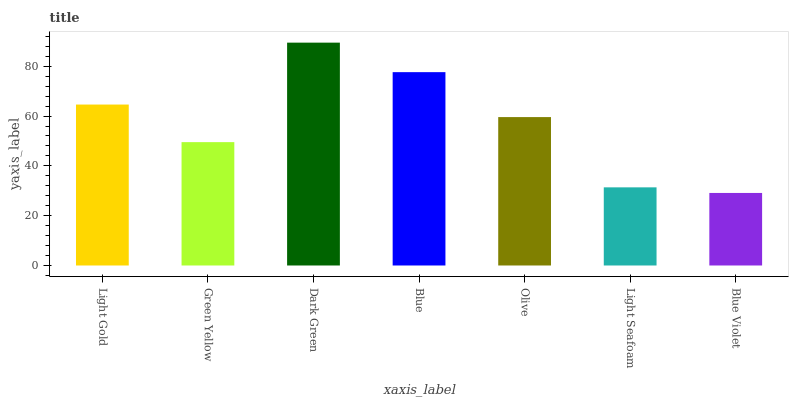Is Blue Violet the minimum?
Answer yes or no. Yes. Is Dark Green the maximum?
Answer yes or no. Yes. Is Green Yellow the minimum?
Answer yes or no. No. Is Green Yellow the maximum?
Answer yes or no. No. Is Light Gold greater than Green Yellow?
Answer yes or no. Yes. Is Green Yellow less than Light Gold?
Answer yes or no. Yes. Is Green Yellow greater than Light Gold?
Answer yes or no. No. Is Light Gold less than Green Yellow?
Answer yes or no. No. Is Olive the high median?
Answer yes or no. Yes. Is Olive the low median?
Answer yes or no. Yes. Is Blue the high median?
Answer yes or no. No. Is Light Seafoam the low median?
Answer yes or no. No. 